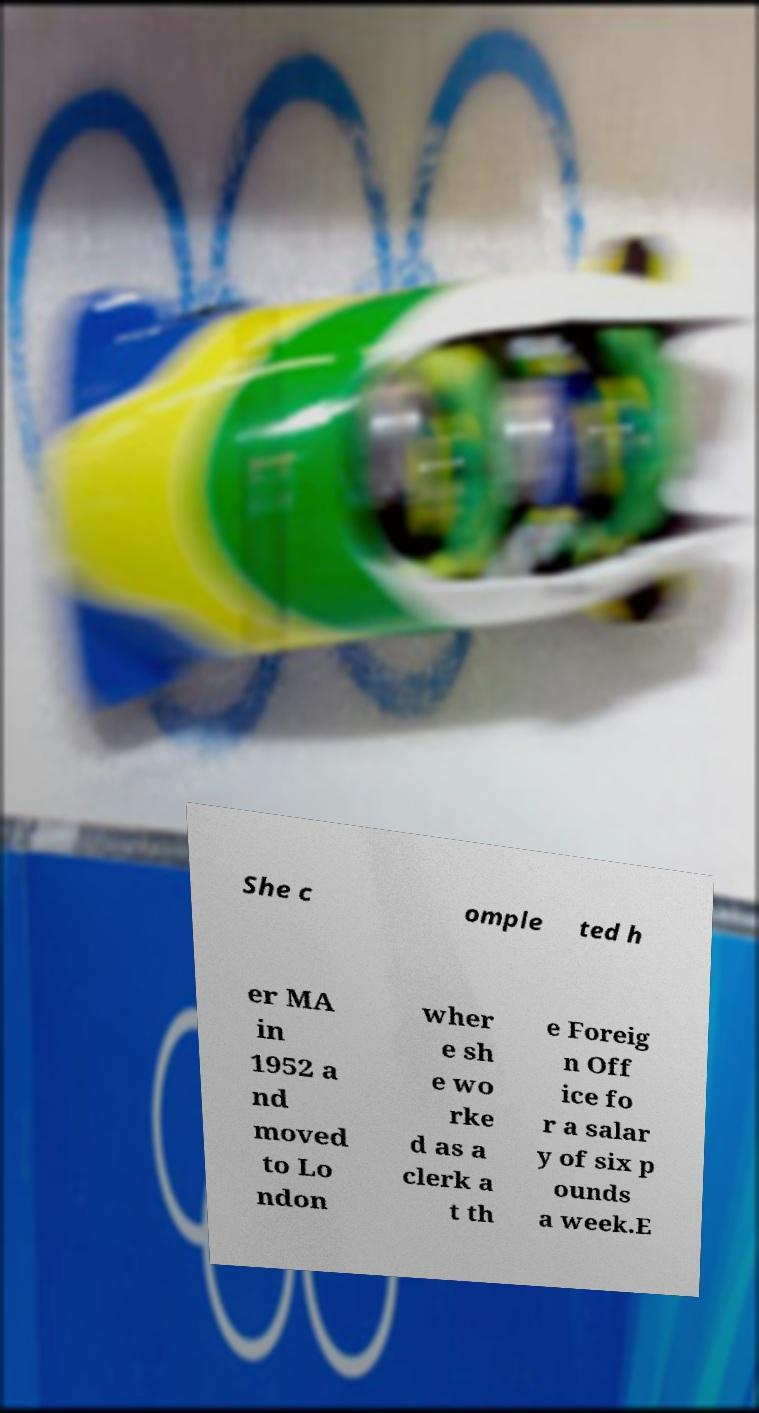Please identify and transcribe the text found in this image. She c omple ted h er MA in 1952 a nd moved to Lo ndon wher e sh e wo rke d as a clerk a t th e Foreig n Off ice fo r a salar y of six p ounds a week.E 